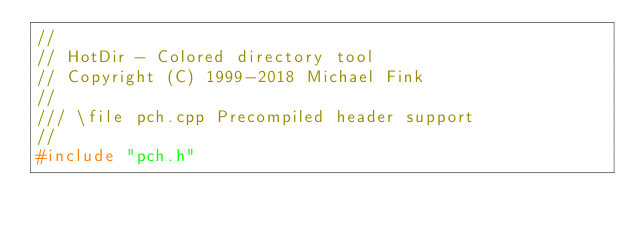<code> <loc_0><loc_0><loc_500><loc_500><_C++_>//
// HotDir - Colored directory tool
// Copyright (C) 1999-2018 Michael Fink
//
/// \file pch.cpp Precompiled header support
//
#include "pch.h"
</code> 